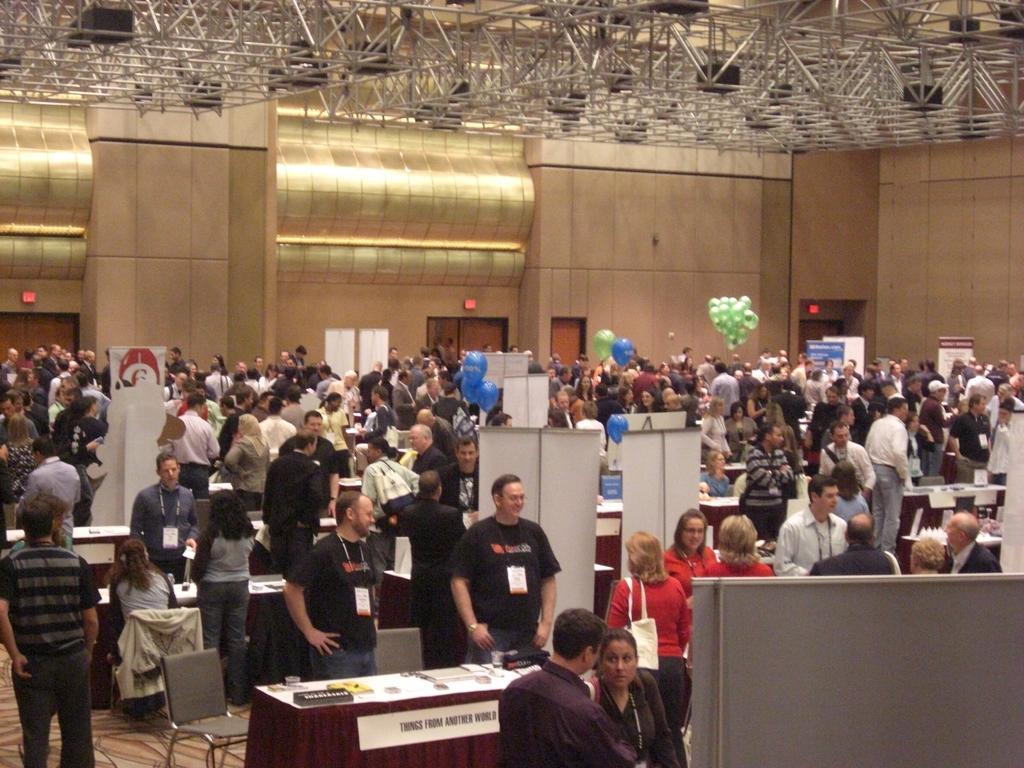Describe this image in one or two sentences. This image is clicked inside a room. There are tables and chairs in the room. There are many people standing and a few sitting. They all are wearing identity cards around their neck. In the background there is a wall. There are doors to the wall. There are balloons in the image. In the top there are metal rods to the ceiling. 